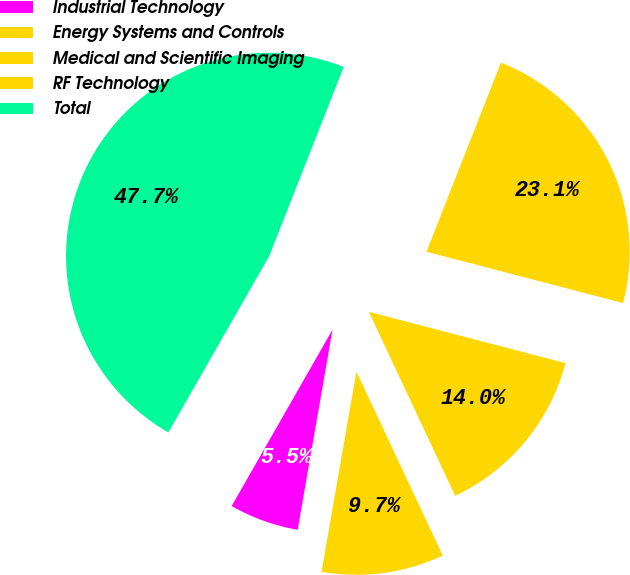<chart> <loc_0><loc_0><loc_500><loc_500><pie_chart><fcel>Industrial Technology<fcel>Energy Systems and Controls<fcel>Medical and Scientific Imaging<fcel>RF Technology<fcel>Total<nl><fcel>5.52%<fcel>9.73%<fcel>13.95%<fcel>23.09%<fcel>47.7%<nl></chart> 